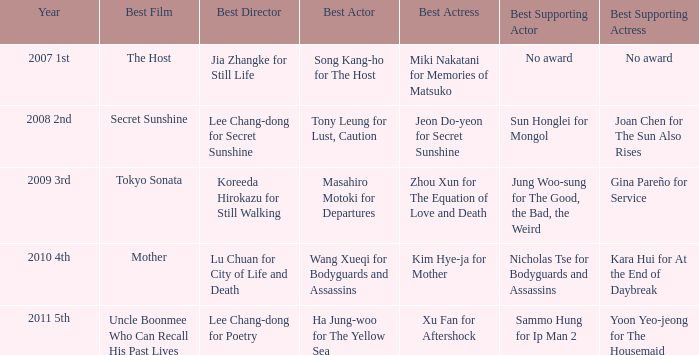Identify the top supporting actress alongside sun honglei in mongol. Joan Chen for The Sun Also Rises. 